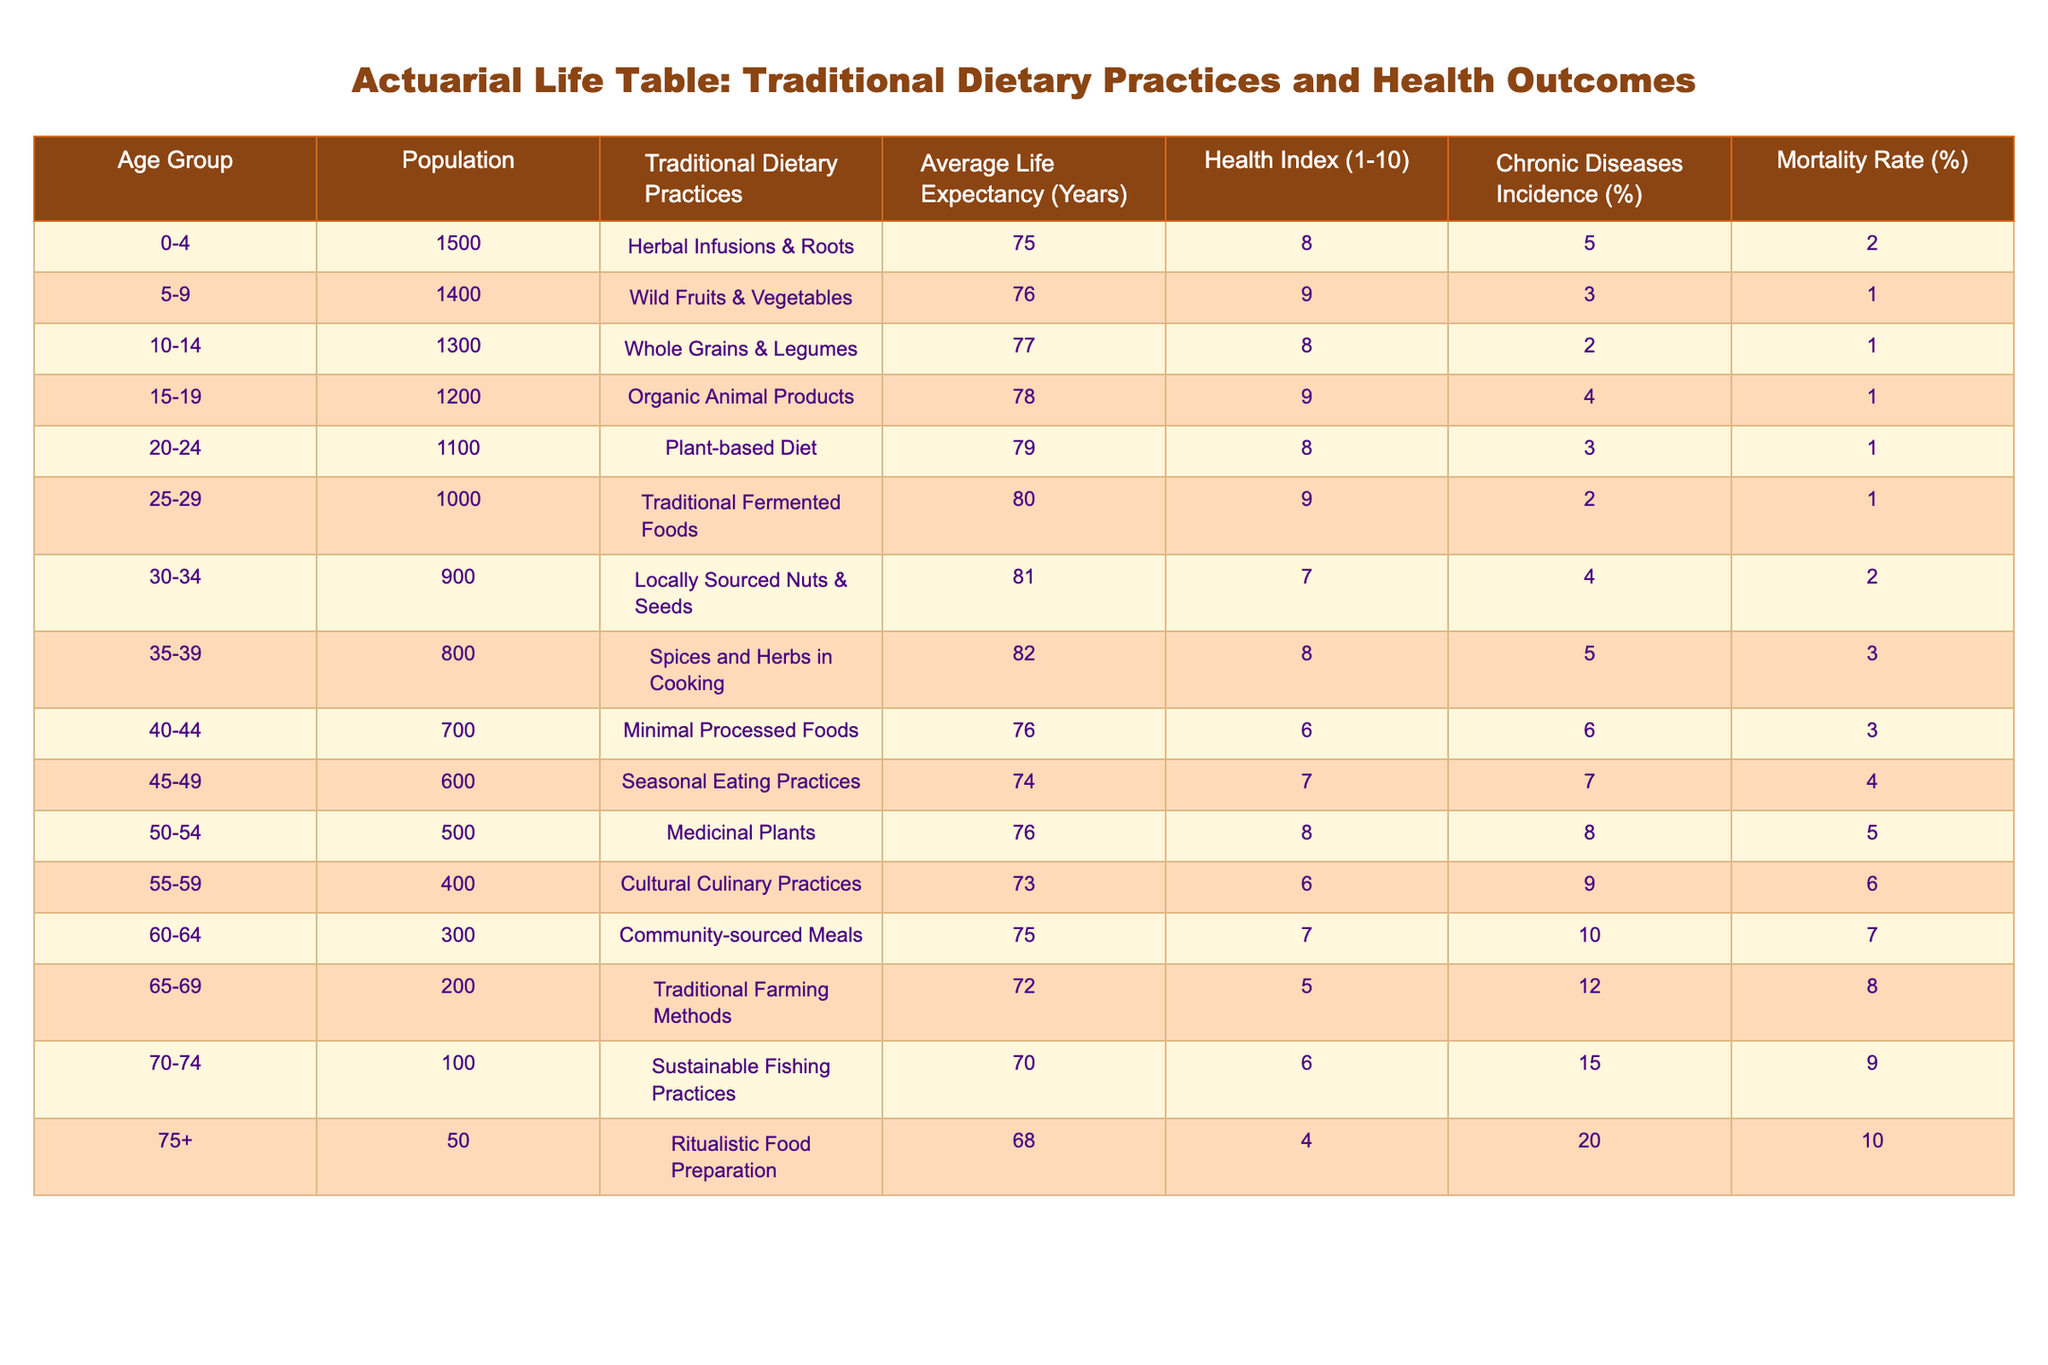What is the average life expectancy for individuals aged 50-54? The life expectancy for the age group 50-54 is explicitly listed in the table. It is stated to be 76 years.
Answer: 76 What is the health index for the age group 35-39? The health index for the age group 35-39 is straightforwardly provided in the table, which indicates a health index of 8.
Answer: 8 What percentage of individuals aged 70-74 experience chronic diseases? The chronic diseases incidence for the age group 70-74 is given in the table, appearing as 15%.
Answer: 15% Are traditional dietary practices associated with lower mortality rates? To evaluate this, we can analyze the mortality rates across age groups: from 0-4 to 75+. Most groups practicing traditional diets have lower mortality rates compared to those in the last age groups (like 75+ with 10%). Thus, it can be concluded that traditional practices are generally linked with lower mortality rates in younger populations.
Answer: Yes What is the difference in average life expectancy between the age groups 55-59 and 65-69? The average life expectancy for 55-59 is 73 years, and for 65-69 it is 72 years. Calculating the difference gives us 73 - 72 = 1, indicating that individuals in the 55-59 bracket have a one-year higher life expectancy.
Answer: 1 year What is the health index for the age group with the highest chronic diseases incidence? The age group with the highest chronic diseases incidence is 75+ with an incidence of 20%. The corresponding health index for this group is 4, as noted in the table.
Answer: 4 Which age group has the lowest health index, and what is that value? Analyzing the table shows the lowest health index is for the age group 75+, where it is indicated as 4.
Answer: 4 What is the average health index for age groups that follow plant-based or organic diets? The relevant age groups that adhere to either a plant-based diet (20-24, health index of 8) or organic animal products (15-19, health index of 9). Calculating the average: (8 + 9) / 2 = 8.5.
Answer: 8.5 What can be inferred about the correlation between age and life expectancy based on the table? A trend is noted in the table where earlier age groups exhibit increasing life expectancy, peaking before gradual declines are observed in older age brackets, suggesting a potential negative correlation as age increases.
Answer: Negative correlation 